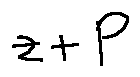Convert formula to latex. <formula><loc_0><loc_0><loc_500><loc_500>z + P</formula> 